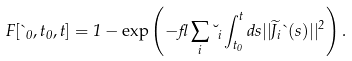Convert formula to latex. <formula><loc_0><loc_0><loc_500><loc_500>F [ \theta _ { 0 } , t _ { 0 } , t ] = 1 - \exp \left ( - \gamma \sum _ { i } \lambda _ { i } \int _ { t _ { 0 } } ^ { t } d s | | \widetilde { J } _ { i } \theta ( s ) | | ^ { 2 } \right ) .</formula> 